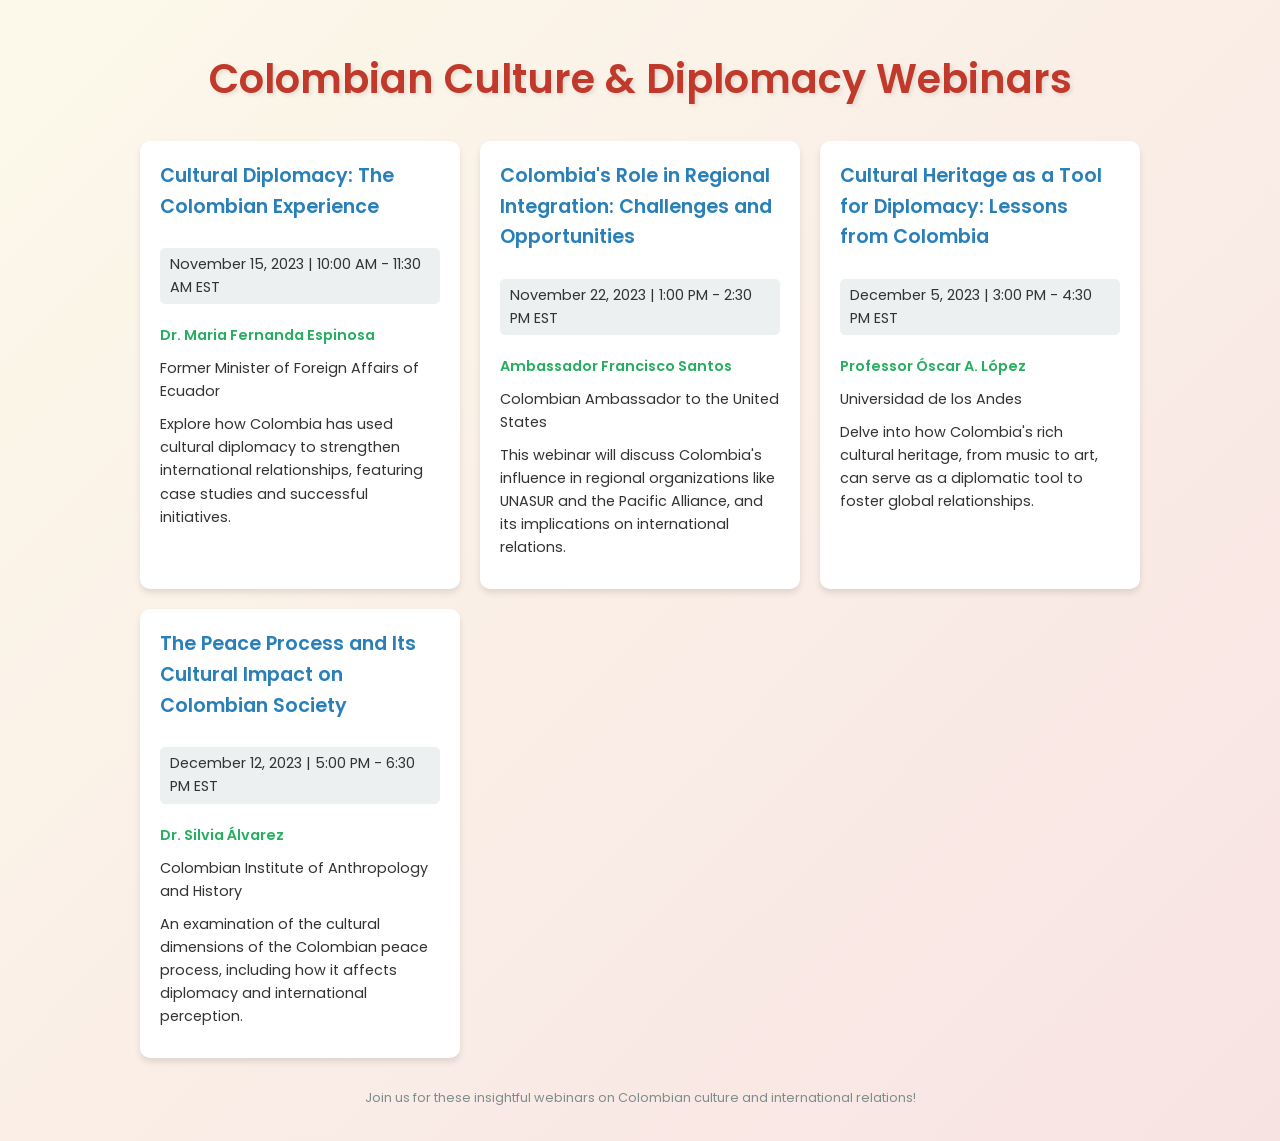What is the title of the first webinar? The title of the first webinar is found in the section describing the first event in the document.
Answer: Cultural Diplomacy: The Colombian Experience Who is the speaker of the webinar on December 5, 2023? The speaker's name is listed in the details of the webinar on December 5, 2023.
Answer: Professor Óscar A. López Which institution is Dr. Silvia Álvarez associated with? This information is included in the details of the webinar about the peace process and its cultural impact.
Answer: Colombian Institute of Anthropology and History How many webinars are listed in the document? The total number of webinars can be counted from the specific entries shown in the document.
Answer: Four What theme connects all the upcoming webinars? The overarching theme can be inferred from the titles and descriptions of each webinar.
Answer: Colombian culture and international relations What is the main focus of the webinar on November 15, 2023? The focus can be determined from the description provided with that webinar's details.
Answer: Cultural diplomacy in Colombia Which country’s former Minister of Foreign Affairs is a speaker? The speaker's identity reveals their country of association, mentioned in their description.
Answer: Ecuador 